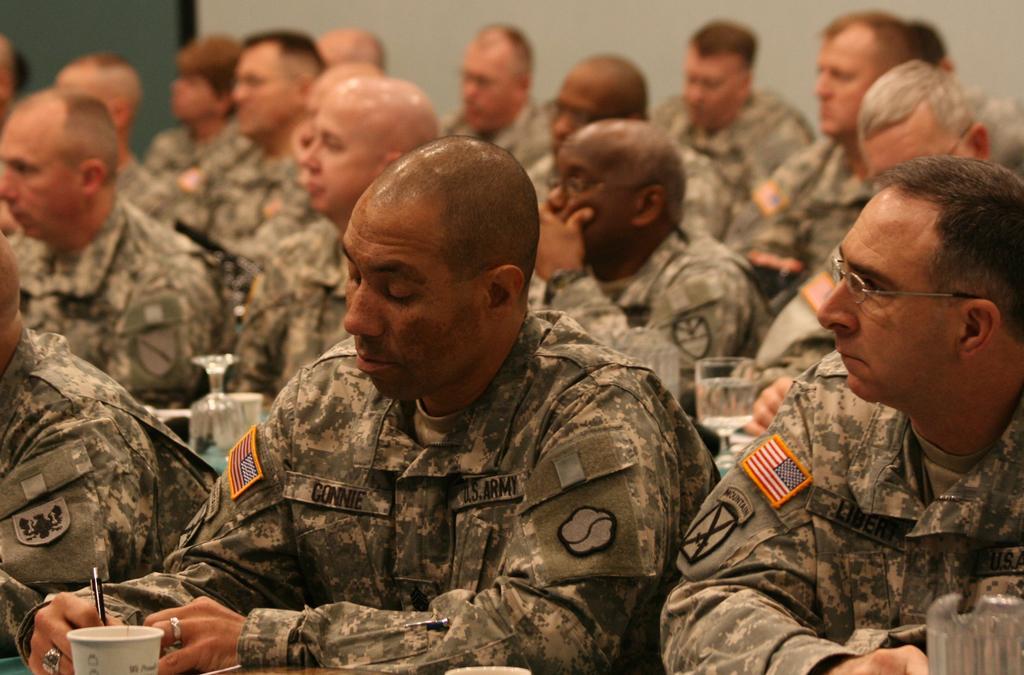In one or two sentences, can you explain what this image depicts? In this image I can see soldiers and a glass at the front. 